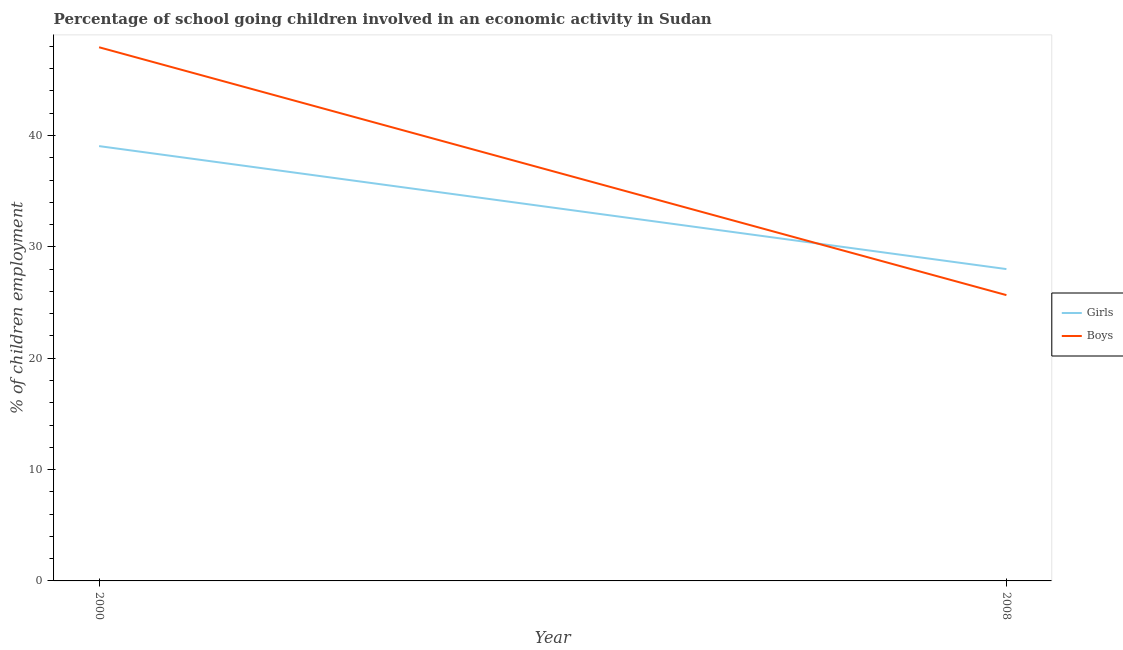How many different coloured lines are there?
Offer a very short reply. 2. Does the line corresponding to percentage of school going boys intersect with the line corresponding to percentage of school going girls?
Provide a short and direct response. Yes. What is the percentage of school going girls in 2008?
Offer a terse response. 28. Across all years, what is the maximum percentage of school going boys?
Offer a terse response. 47.92. Across all years, what is the minimum percentage of school going boys?
Offer a very short reply. 25.67. In which year was the percentage of school going boys maximum?
Provide a short and direct response. 2000. In which year was the percentage of school going boys minimum?
Give a very brief answer. 2008. What is the total percentage of school going boys in the graph?
Ensure brevity in your answer.  73.59. What is the difference between the percentage of school going girls in 2000 and that in 2008?
Provide a succinct answer. 11.04. What is the difference between the percentage of school going girls in 2008 and the percentage of school going boys in 2000?
Your answer should be very brief. -19.92. What is the average percentage of school going boys per year?
Make the answer very short. 36.79. In the year 2000, what is the difference between the percentage of school going boys and percentage of school going girls?
Make the answer very short. 8.88. In how many years, is the percentage of school going boys greater than 42 %?
Make the answer very short. 1. What is the ratio of the percentage of school going girls in 2000 to that in 2008?
Your response must be concise. 1.39. Is the percentage of school going boys in 2000 less than that in 2008?
Offer a very short reply. No. In how many years, is the percentage of school going boys greater than the average percentage of school going boys taken over all years?
Keep it short and to the point. 1. Does the percentage of school going boys monotonically increase over the years?
Provide a short and direct response. No. Is the percentage of school going girls strictly greater than the percentage of school going boys over the years?
Your response must be concise. No. How many lines are there?
Offer a very short reply. 2. What is the difference between two consecutive major ticks on the Y-axis?
Offer a very short reply. 10. Are the values on the major ticks of Y-axis written in scientific E-notation?
Your response must be concise. No. Does the graph contain any zero values?
Make the answer very short. No. What is the title of the graph?
Provide a short and direct response. Percentage of school going children involved in an economic activity in Sudan. What is the label or title of the Y-axis?
Offer a terse response. % of children employment. What is the % of children employment of Girls in 2000?
Make the answer very short. 39.05. What is the % of children employment of Boys in 2000?
Offer a very short reply. 47.92. What is the % of children employment of Girls in 2008?
Your answer should be compact. 28. What is the % of children employment in Boys in 2008?
Your answer should be very brief. 25.67. Across all years, what is the maximum % of children employment of Girls?
Give a very brief answer. 39.05. Across all years, what is the maximum % of children employment of Boys?
Keep it short and to the point. 47.92. Across all years, what is the minimum % of children employment of Girls?
Your answer should be compact. 28. Across all years, what is the minimum % of children employment of Boys?
Make the answer very short. 25.67. What is the total % of children employment in Girls in the graph?
Your answer should be compact. 67.05. What is the total % of children employment in Boys in the graph?
Offer a terse response. 73.59. What is the difference between the % of children employment of Girls in 2000 and that in 2008?
Keep it short and to the point. 11.04. What is the difference between the % of children employment of Boys in 2000 and that in 2008?
Your response must be concise. 22.26. What is the difference between the % of children employment in Girls in 2000 and the % of children employment in Boys in 2008?
Make the answer very short. 13.38. What is the average % of children employment in Girls per year?
Offer a very short reply. 33.52. What is the average % of children employment in Boys per year?
Offer a very short reply. 36.79. In the year 2000, what is the difference between the % of children employment in Girls and % of children employment in Boys?
Your response must be concise. -8.88. In the year 2008, what is the difference between the % of children employment of Girls and % of children employment of Boys?
Provide a succinct answer. 2.34. What is the ratio of the % of children employment in Girls in 2000 to that in 2008?
Keep it short and to the point. 1.39. What is the ratio of the % of children employment of Boys in 2000 to that in 2008?
Provide a succinct answer. 1.87. What is the difference between the highest and the second highest % of children employment of Girls?
Your answer should be compact. 11.04. What is the difference between the highest and the second highest % of children employment in Boys?
Make the answer very short. 22.26. What is the difference between the highest and the lowest % of children employment of Girls?
Your response must be concise. 11.04. What is the difference between the highest and the lowest % of children employment in Boys?
Offer a terse response. 22.26. 